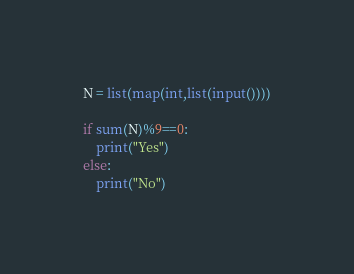Convert code to text. <code><loc_0><loc_0><loc_500><loc_500><_Python_>N = list(map(int,list(input())))

if sum(N)%9==0:
    print("Yes")
else:
    print("No")</code> 